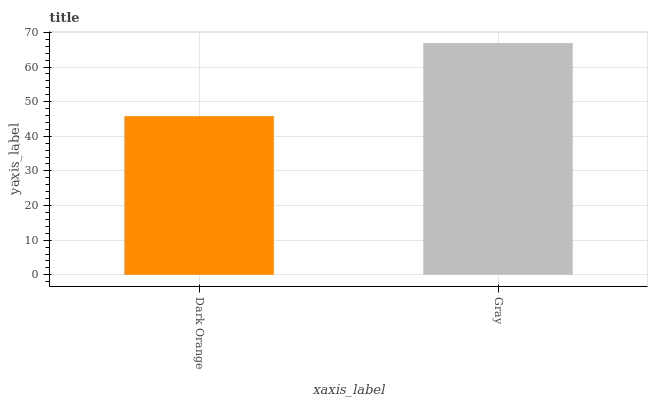Is Gray the minimum?
Answer yes or no. No. Is Gray greater than Dark Orange?
Answer yes or no. Yes. Is Dark Orange less than Gray?
Answer yes or no. Yes. Is Dark Orange greater than Gray?
Answer yes or no. No. Is Gray less than Dark Orange?
Answer yes or no. No. Is Gray the high median?
Answer yes or no. Yes. Is Dark Orange the low median?
Answer yes or no. Yes. Is Dark Orange the high median?
Answer yes or no. No. Is Gray the low median?
Answer yes or no. No. 